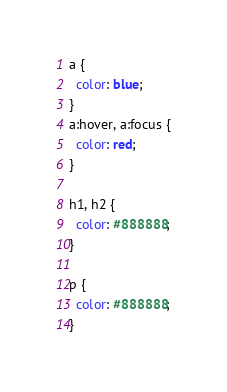Convert code to text. <code><loc_0><loc_0><loc_500><loc_500><_CSS_>a {
  color: blue;
}
a:hover, a:focus {
  color: red;
}

h1, h2 {
  color: #888888;
}

p {
  color: #888888;
}
</code> 